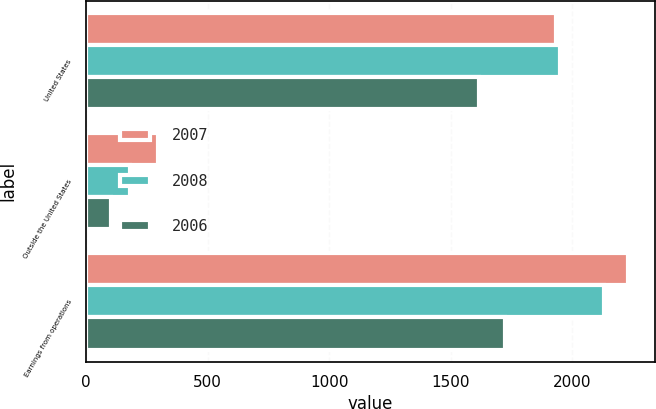Convert chart. <chart><loc_0><loc_0><loc_500><loc_500><stacked_bar_chart><ecel><fcel>United States<fcel>Outside the United States<fcel>Earnings from operations<nl><fcel>2007<fcel>1931<fcel>297<fcel>2228<nl><fcel>2008<fcel>1949<fcel>181<fcel>2130<nl><fcel>2006<fcel>1617<fcel>104<fcel>1721<nl></chart> 